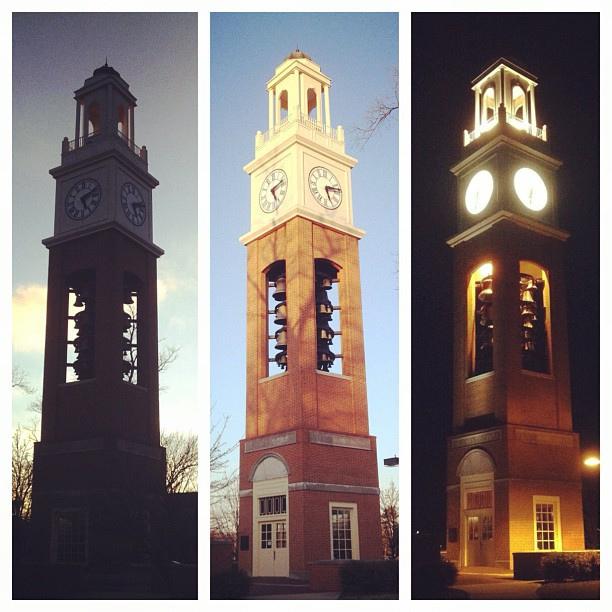Is the clock face illuminated in one of the pictures?
Answer briefly. Yes. What are the names of the 3 times of day pictured here?
Be succinct. Noon, night, morning. Are these all from the same angle?
Write a very short answer. Yes. 